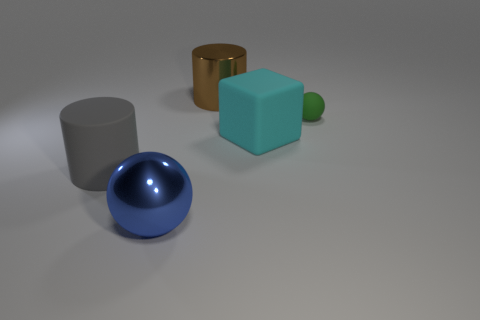Add 5 rubber things. How many objects exist? 10 Subtract all blocks. How many objects are left? 4 Add 5 small green spheres. How many small green spheres exist? 6 Subtract 0 blue cubes. How many objects are left? 5 Subtract all blue shiny things. Subtract all tiny rubber things. How many objects are left? 3 Add 1 small green matte objects. How many small green matte objects are left? 2 